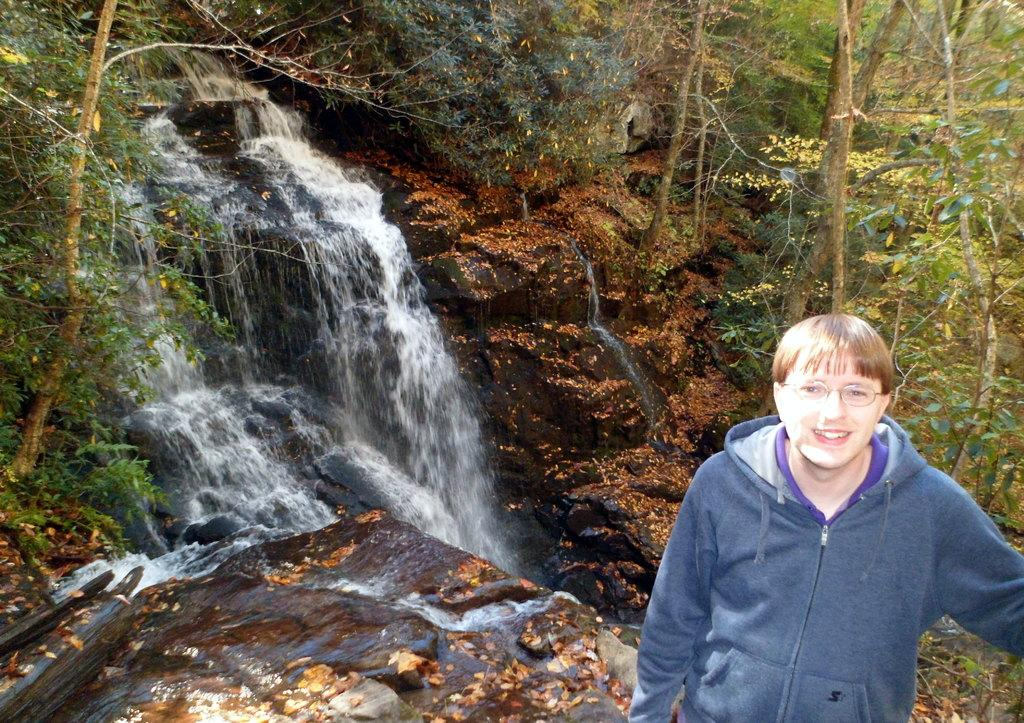Who is present in the image? There is a person in the image. What is the person wearing on their face? The person is wearing glasses. What type of clothing is the person wearing on their upper body? The person is wearing a jacket. What can be seen in the background of the image? There are many trees in the background of the image. What natural feature is visible in the image? A waterfall is visible in the image. What type of crack is present in the person's mind in the image? There is no mention of a crack or the person's mind in the image; it only shows a person wearing glasses and a jacket, surrounded by trees and a waterfall. 